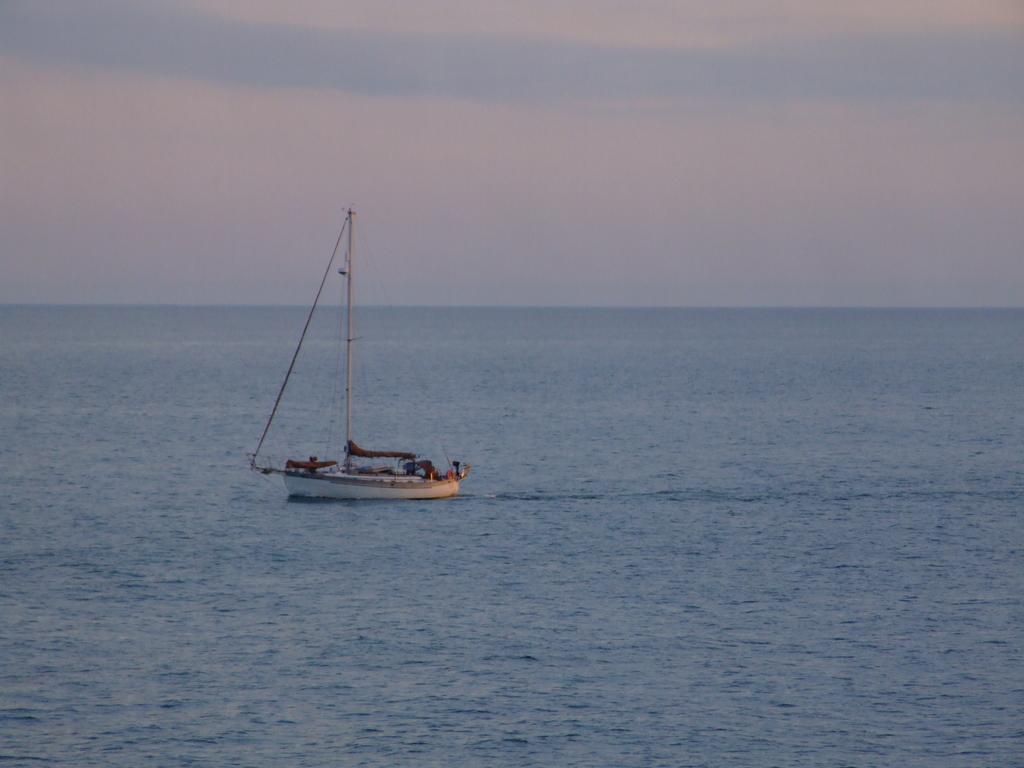Can you describe this image briefly? In the center of the image a boat is there. In the background of the image we can see the water. At the top of the image we can see the sky. 